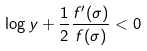Convert formula to latex. <formula><loc_0><loc_0><loc_500><loc_500>\log y + \frac { 1 } { 2 } \frac { f ^ { \prime } ( \sigma ) } { f ( \sigma ) } < 0</formula> 